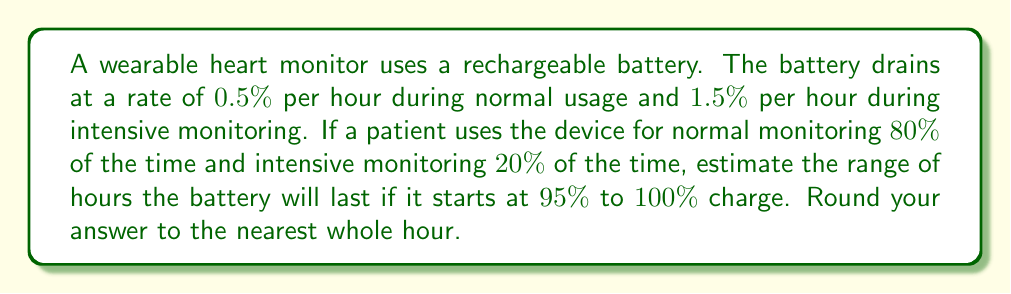Could you help me with this problem? Let's approach this step-by-step:

1) First, calculate the average drain rate:
   Normal usage: $80\% \times 0.5\% = 0.4\%$ per hour
   Intensive usage: $20\% \times 1.5\% = 0.3\%$ per hour
   Average drain rate: $0.4\% + 0.3\% = 0.7\%$ per hour

2) Now, set up inequalities for the battery life:
   Let $x$ be the number of hours the battery lasts.
   
   Lower bound: $95 - 0.7x \geq 0$
   Upper bound: $100 - 0.7x \geq 0$

3) Solve these inequalities:
   Lower bound: $95 - 0.7x \geq 0$
                $-0.7x \geq -95$
                $0.7x \leq 95$
                $x \leq 135.71$

   Upper bound: $100 - 0.7x \geq 0$
                $-0.7x \geq -100$
                $0.7x \leq 100$
                $x \leq 142.86$

4) Rounding to the nearest whole hour:
   Lower bound: 136 hours
   Upper bound: 143 hours

Therefore, the battery will last between 136 and 143 hours.
Answer: 136 to 143 hours 